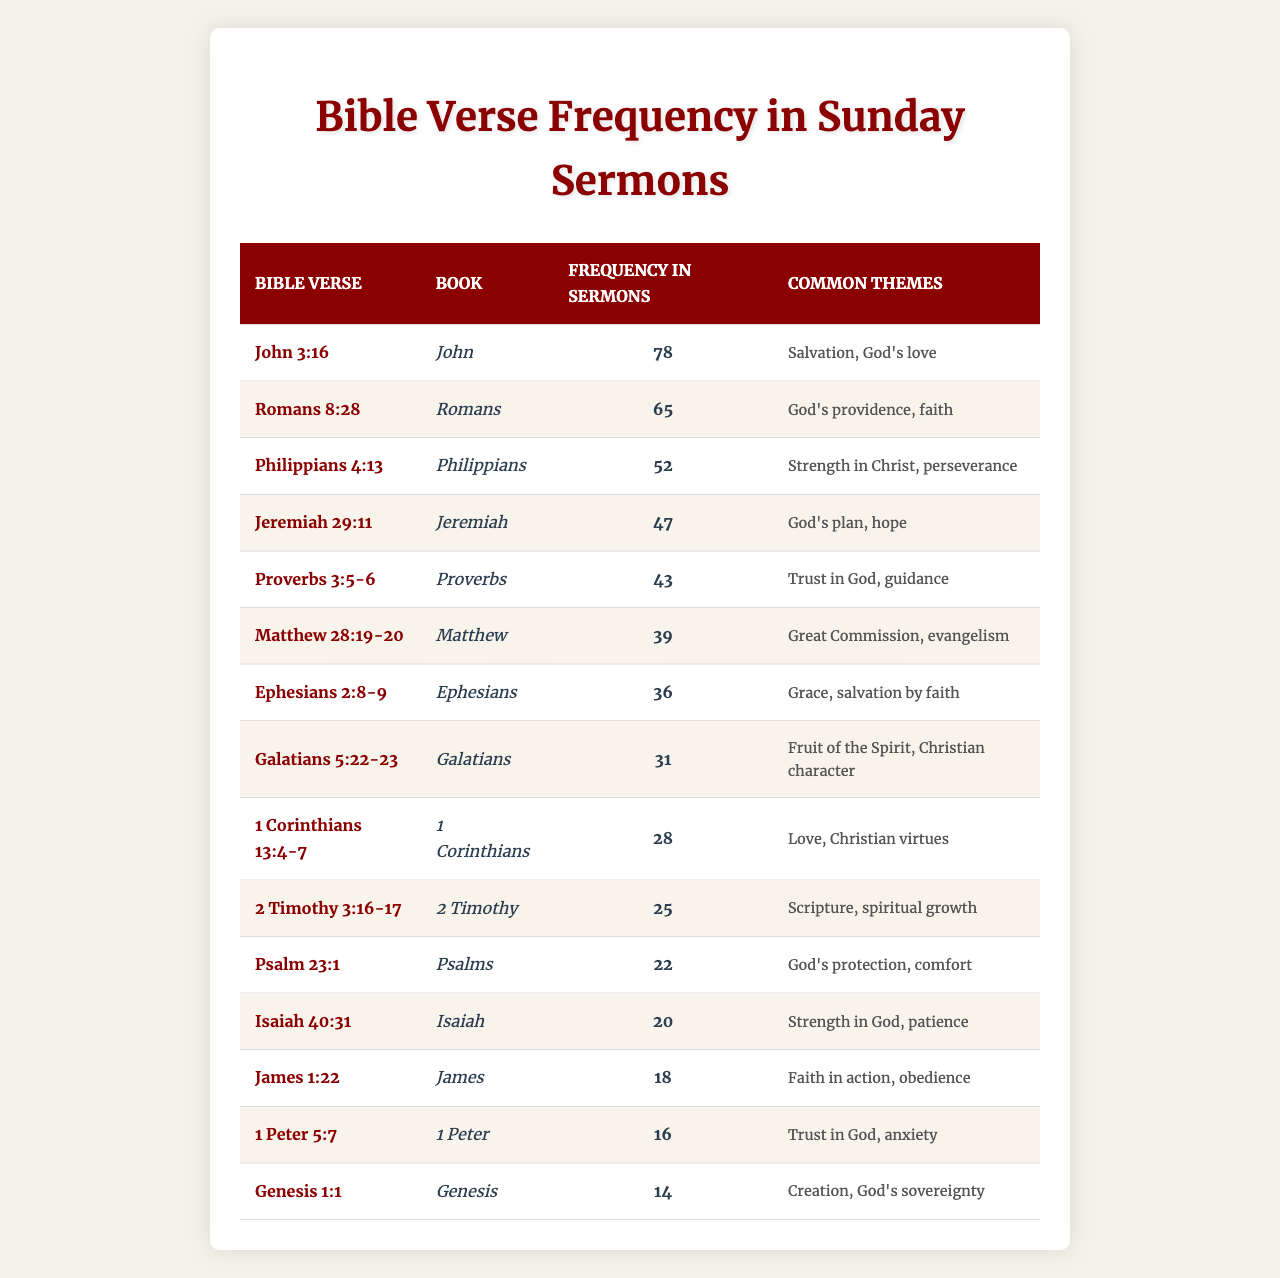What is the most frequently referenced Bible verse in sermons? The table shows John 3:16 with a frequency of 78, making it the most mentioned verse.
Answer: John 3:16 How many times is Romans 8:28 referenced in sermons? The table indicates that Romans 8:28 is mentioned 65 times.
Answer: 65 Which Bible verse is associated with the themes of patience and strength in God? Isaiah 40:31, listed in the table, relates to strength in God and patience.
Answer: Isaiah 40:31 What is the total frequency of the top three Bible verses? The frequencies of the top three verses are 78 (John 3:16), 65 (Romans 8:28), and 52 (Philippians 4:13). The total frequency is 78 + 65 + 52 = 195.
Answer: 195 Is there a Bible verse associated with trust in God and guidance? Yes, Proverbs 3:5-6 is connected with trust in God and guidance, as stated in the table.
Answer: Yes Which book of the Bible is referenced the least in sermons? Genesis is mentioned 14 times, making it the least referenced book in the data provided.
Answer: Genesis What is the average frequency of the Bible verses listed in the table? To find the average, sum the frequencies (78 + 65 + 52 + 47 + 43 + 39 + 36 + 31 + 28 + 25 + 22 + 20 + 18 + 16 + 14 =  576) and divide by the total number of verses (15). The average frequency is 576/15 = 38.4.
Answer: 38.4 Which two verses have similar themes of love and Christian virtues? 1 Corinthians 13:4-7, focused on love and Christian virtues, aligns closely with the theme of love. Both verses likely emphasize love's importance in Christian faith.
Answer: 1 Corinthians 13:4-7 Do more sermons reference verses about salvation or guidance? The total frequency for salvation verses (John 3:16, Ephesians 2:8-9) is 78 + 36 = 114. For guidance (Proverbs 3:5-6), it is 43. Since 114 > 43, more sermons reference salvation verses.
Answer: Yes Which Bible verse is most closely related to the theme of God's providence? Romans 8:28 is explicitly linked to God's providence, as indicated in the themes column of the table.
Answer: Romans 8:28 